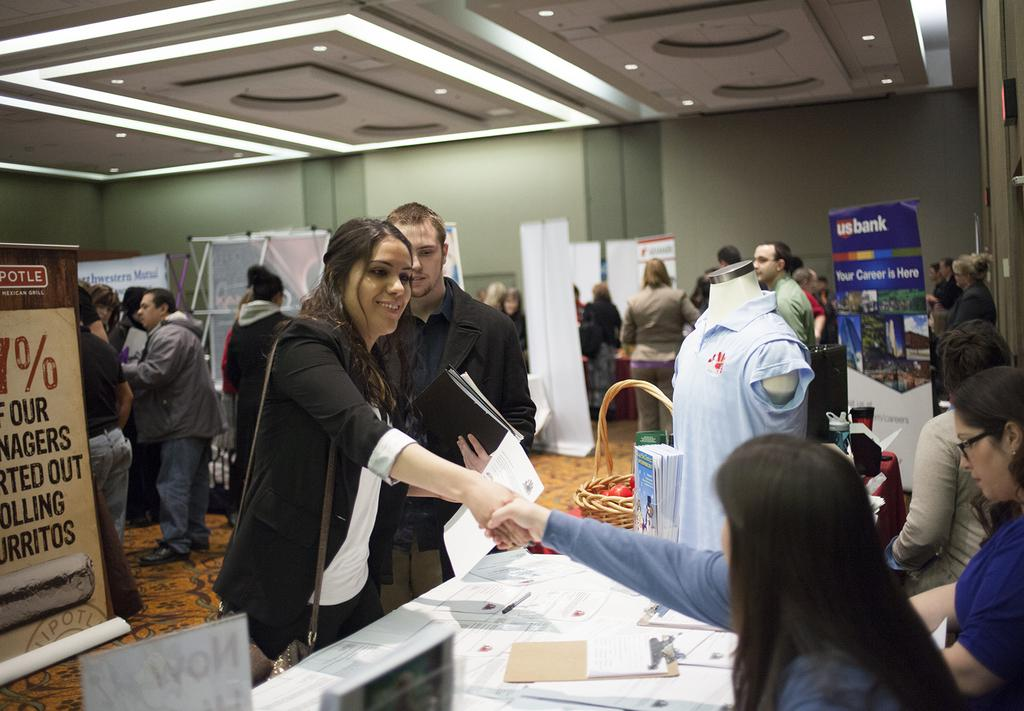<image>
Summarize the visual content of the image. Two women shaking hands, in the background a blue board reads US bank. 